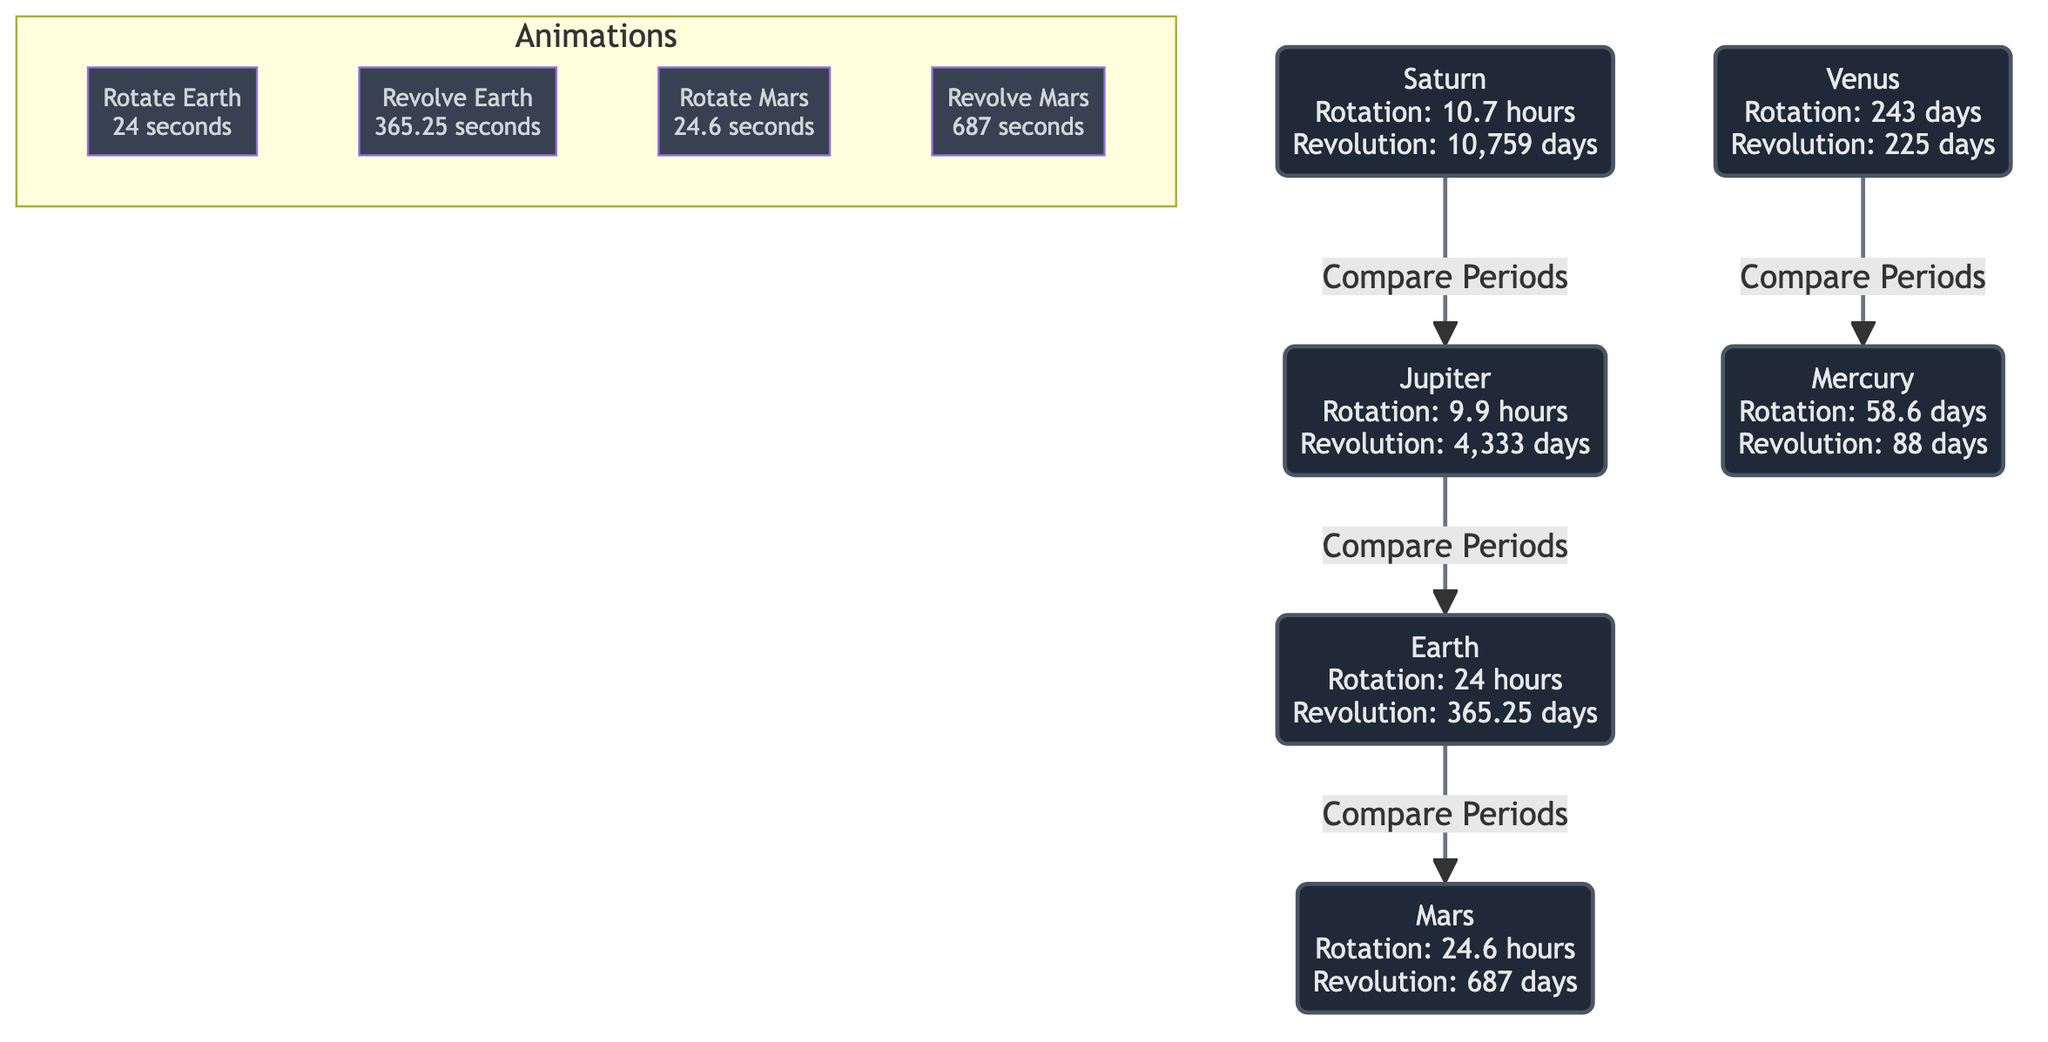What is the rotation period of Earth? The diagram lists Earth's rotation period as "24 hours." To answer, I find the node corresponding to Earth and read the associated information.
Answer: 24 hours What is the revolution period of Jupiter? Jupiter's revolution period is shown as "4,333 days." I locate the Jupiter node on the diagram to extract this information.
Answer: 4,333 days How many planets are compared in the diagram? The diagram includes six distinct nodes representing different planets (Earth, Mars, Jupiter, Saturn, Venus, Mercury). Counting these nodes gives the total number of planets.
Answer: 6 Which planet has the longest rotation period? By examining the rotation periods listed in the diagram, I see that Venus, with a rotation period of "243 days," has the longest one compared to the others.
Answer: Venus How does Earth's revolution period compare to Mars'? The diagram states that Earth's revolution period is "365.25 days," while Mars' is "687 days." Since 687 days is greater than 365.25 days, Mars takes longer to revolve around the Sun compared to Earth.
Answer: Mars What is the relationship between Jupiter and Saturn in the diagram? The diagram shows a directional edge labeled "Compare Periods" from Saturn to Jupiter, indicating a comparative relationship where they are linked based on their periods.
Answer: Compare Periods Which planets have a rotation period less than 24 hours? Examining the rotation periods, Earth is listed as 24 hours, and Mars as 24.6 hours, but both Jupiter (9.9 hours) and Saturn (10.7 hours) have less than 24 hours. I conclude by checking all rotation values.
Answer: Jupiter, Saturn What is the interactive learning feature associated with Earth? The diagram provides subgraph nodes labeled "Rotate Earth" and "Revolve Earth," with information on the associated time durations—"24 seconds" for rotation and "365.25 seconds" for revolution—indicating interactive animations for learning.
Answer: Rotate Earth, Revolve Earth What is the shortest revolution period among the listed planets? In reviewing the revolution periods on the diagram, Mercury has the shortest period at "88 days," as it is less than all other recorded values for the planets shown.
Answer: 88 days 